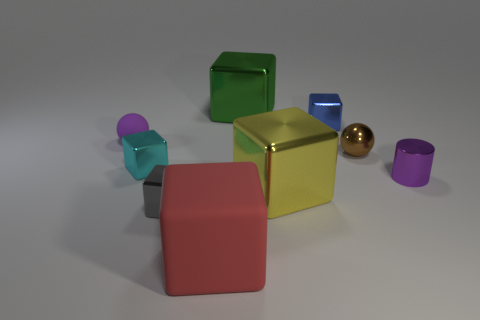Subtract all green cubes. How many cubes are left? 5 Add 1 brown balls. How many objects exist? 10 Subtract all cyan blocks. How many blocks are left? 5 Subtract 1 spheres. How many spheres are left? 1 Subtract all green balls. How many purple cubes are left? 0 Subtract all purple spheres. Subtract all large matte objects. How many objects are left? 7 Add 1 cyan metal blocks. How many cyan metal blocks are left? 2 Add 3 tiny blue rubber cubes. How many tiny blue rubber cubes exist? 3 Subtract 0 green cylinders. How many objects are left? 9 Subtract all spheres. How many objects are left? 7 